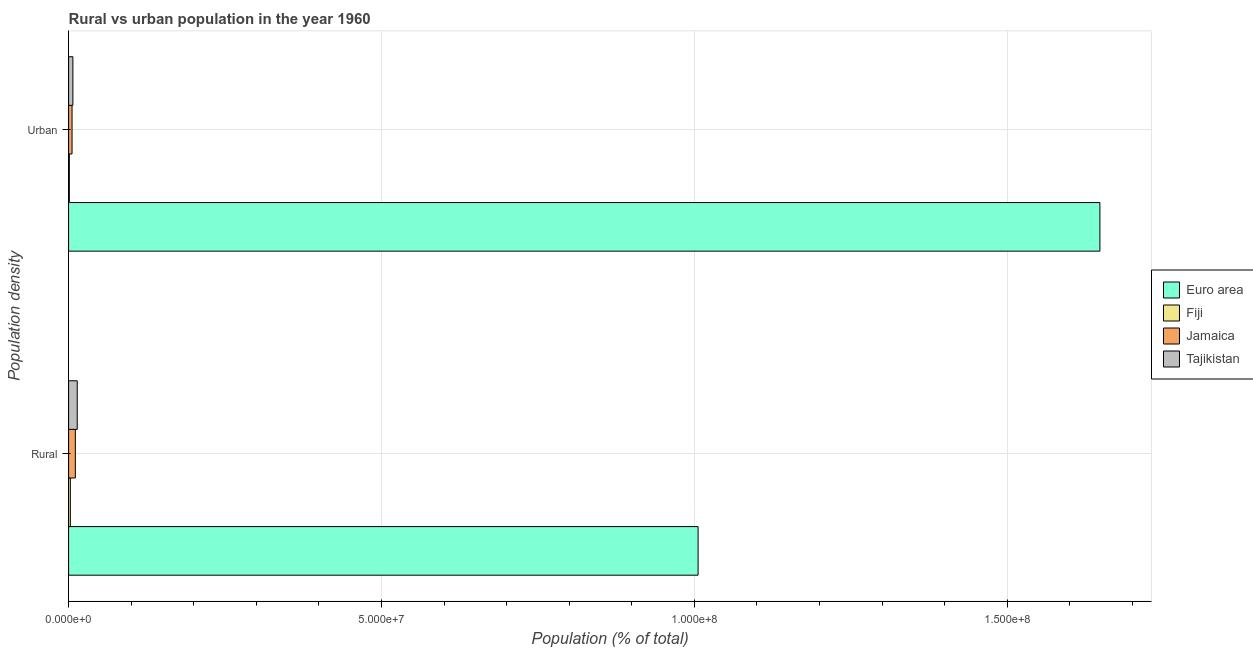How many groups of bars are there?
Offer a very short reply. 2. Are the number of bars on each tick of the Y-axis equal?
Ensure brevity in your answer.  Yes. How many bars are there on the 2nd tick from the top?
Offer a very short reply. 4. How many bars are there on the 2nd tick from the bottom?
Offer a very short reply. 4. What is the label of the 1st group of bars from the top?
Provide a succinct answer. Urban. What is the rural population density in Tajikistan?
Your answer should be compact. 1.38e+06. Across all countries, what is the maximum urban population density?
Provide a succinct answer. 1.65e+08. Across all countries, what is the minimum rural population density?
Provide a succinct answer. 2.77e+05. In which country was the urban population density maximum?
Your response must be concise. Euro area. In which country was the rural population density minimum?
Ensure brevity in your answer.  Fiji. What is the total urban population density in the graph?
Your answer should be very brief. 1.66e+08. What is the difference between the urban population density in Fiji and that in Euro area?
Provide a succinct answer. -1.65e+08. What is the difference between the urban population density in Jamaica and the rural population density in Euro area?
Ensure brevity in your answer.  -1.00e+08. What is the average urban population density per country?
Provide a short and direct response. 4.15e+07. What is the difference between the rural population density and urban population density in Fiji?
Offer a terse response. 1.60e+05. What is the ratio of the urban population density in Fiji to that in Jamaica?
Give a very brief answer. 0.21. What does the 3rd bar from the top in Rural represents?
Your answer should be very brief. Fiji. What does the 3rd bar from the bottom in Rural represents?
Make the answer very short. Jamaica. How many countries are there in the graph?
Your answer should be compact. 4. What is the difference between two consecutive major ticks on the X-axis?
Offer a terse response. 5.00e+07. Does the graph contain grids?
Offer a terse response. Yes. How many legend labels are there?
Your answer should be compact. 4. What is the title of the graph?
Provide a short and direct response. Rural vs urban population in the year 1960. What is the label or title of the X-axis?
Give a very brief answer. Population (% of total). What is the label or title of the Y-axis?
Ensure brevity in your answer.  Population density. What is the Population (% of total) of Euro area in Rural?
Your answer should be very brief. 1.01e+08. What is the Population (% of total) of Fiji in Rural?
Make the answer very short. 2.77e+05. What is the Population (% of total) of Jamaica in Rural?
Give a very brief answer. 1.08e+06. What is the Population (% of total) in Tajikistan in Rural?
Offer a terse response. 1.38e+06. What is the Population (% of total) in Euro area in Urban?
Give a very brief answer. 1.65e+08. What is the Population (% of total) of Fiji in Urban?
Offer a terse response. 1.17e+05. What is the Population (% of total) in Jamaica in Urban?
Provide a succinct answer. 5.50e+05. What is the Population (% of total) in Tajikistan in Urban?
Your answer should be compact. 6.85e+05. Across all Population density, what is the maximum Population (% of total) in Euro area?
Keep it short and to the point. 1.65e+08. Across all Population density, what is the maximum Population (% of total) of Fiji?
Make the answer very short. 2.77e+05. Across all Population density, what is the maximum Population (% of total) of Jamaica?
Provide a short and direct response. 1.08e+06. Across all Population density, what is the maximum Population (% of total) in Tajikistan?
Provide a succinct answer. 1.38e+06. Across all Population density, what is the minimum Population (% of total) of Euro area?
Ensure brevity in your answer.  1.01e+08. Across all Population density, what is the minimum Population (% of total) of Fiji?
Your response must be concise. 1.17e+05. Across all Population density, what is the minimum Population (% of total) in Jamaica?
Offer a very short reply. 5.50e+05. Across all Population density, what is the minimum Population (% of total) in Tajikistan?
Provide a short and direct response. 6.85e+05. What is the total Population (% of total) of Euro area in the graph?
Offer a very short reply. 2.65e+08. What is the total Population (% of total) in Fiji in the graph?
Make the answer very short. 3.93e+05. What is the total Population (% of total) of Jamaica in the graph?
Your answer should be compact. 1.63e+06. What is the total Population (% of total) in Tajikistan in the graph?
Offer a terse response. 2.06e+06. What is the difference between the Population (% of total) in Euro area in Rural and that in Urban?
Give a very brief answer. -6.42e+07. What is the difference between the Population (% of total) of Fiji in Rural and that in Urban?
Keep it short and to the point. 1.60e+05. What is the difference between the Population (% of total) in Jamaica in Rural and that in Urban?
Your answer should be very brief. 5.29e+05. What is the difference between the Population (% of total) in Tajikistan in Rural and that in Urban?
Offer a terse response. 6.95e+05. What is the difference between the Population (% of total) in Euro area in Rural and the Population (% of total) in Fiji in Urban?
Keep it short and to the point. 1.00e+08. What is the difference between the Population (% of total) of Euro area in Rural and the Population (% of total) of Jamaica in Urban?
Offer a very short reply. 1.00e+08. What is the difference between the Population (% of total) of Euro area in Rural and the Population (% of total) of Tajikistan in Urban?
Keep it short and to the point. 9.99e+07. What is the difference between the Population (% of total) in Fiji in Rural and the Population (% of total) in Jamaica in Urban?
Your answer should be very brief. -2.73e+05. What is the difference between the Population (% of total) in Fiji in Rural and the Population (% of total) in Tajikistan in Urban?
Give a very brief answer. -4.08e+05. What is the difference between the Population (% of total) of Jamaica in Rural and the Population (% of total) of Tajikistan in Urban?
Your response must be concise. 3.94e+05. What is the average Population (% of total) of Euro area per Population density?
Provide a short and direct response. 1.33e+08. What is the average Population (% of total) of Fiji per Population density?
Make the answer very short. 1.97e+05. What is the average Population (% of total) of Jamaica per Population density?
Your response must be concise. 8.15e+05. What is the average Population (% of total) of Tajikistan per Population density?
Make the answer very short. 1.03e+06. What is the difference between the Population (% of total) of Euro area and Population (% of total) of Fiji in Rural?
Provide a succinct answer. 1.00e+08. What is the difference between the Population (% of total) in Euro area and Population (% of total) in Jamaica in Rural?
Give a very brief answer. 9.95e+07. What is the difference between the Population (% of total) in Euro area and Population (% of total) in Tajikistan in Rural?
Give a very brief answer. 9.92e+07. What is the difference between the Population (% of total) in Fiji and Population (% of total) in Jamaica in Rural?
Your answer should be very brief. -8.02e+05. What is the difference between the Population (% of total) in Fiji and Population (% of total) in Tajikistan in Rural?
Your response must be concise. -1.10e+06. What is the difference between the Population (% of total) in Jamaica and Population (% of total) in Tajikistan in Rural?
Provide a succinct answer. -3.01e+05. What is the difference between the Population (% of total) in Euro area and Population (% of total) in Fiji in Urban?
Provide a succinct answer. 1.65e+08. What is the difference between the Population (% of total) of Euro area and Population (% of total) of Jamaica in Urban?
Your answer should be very brief. 1.64e+08. What is the difference between the Population (% of total) of Euro area and Population (% of total) of Tajikistan in Urban?
Offer a terse response. 1.64e+08. What is the difference between the Population (% of total) of Fiji and Population (% of total) of Jamaica in Urban?
Your answer should be very brief. -4.33e+05. What is the difference between the Population (% of total) of Fiji and Population (% of total) of Tajikistan in Urban?
Ensure brevity in your answer.  -5.68e+05. What is the difference between the Population (% of total) in Jamaica and Population (% of total) in Tajikistan in Urban?
Give a very brief answer. -1.35e+05. What is the ratio of the Population (% of total) of Euro area in Rural to that in Urban?
Make the answer very short. 0.61. What is the ratio of the Population (% of total) in Fiji in Rural to that in Urban?
Your response must be concise. 2.37. What is the ratio of the Population (% of total) in Jamaica in Rural to that in Urban?
Your answer should be compact. 1.96. What is the ratio of the Population (% of total) of Tajikistan in Rural to that in Urban?
Make the answer very short. 2.02. What is the difference between the highest and the second highest Population (% of total) in Euro area?
Your answer should be very brief. 6.42e+07. What is the difference between the highest and the second highest Population (% of total) in Fiji?
Your answer should be compact. 1.60e+05. What is the difference between the highest and the second highest Population (% of total) in Jamaica?
Your response must be concise. 5.29e+05. What is the difference between the highest and the second highest Population (% of total) in Tajikistan?
Offer a terse response. 6.95e+05. What is the difference between the highest and the lowest Population (% of total) in Euro area?
Keep it short and to the point. 6.42e+07. What is the difference between the highest and the lowest Population (% of total) of Fiji?
Offer a terse response. 1.60e+05. What is the difference between the highest and the lowest Population (% of total) of Jamaica?
Your answer should be very brief. 5.29e+05. What is the difference between the highest and the lowest Population (% of total) of Tajikistan?
Provide a short and direct response. 6.95e+05. 